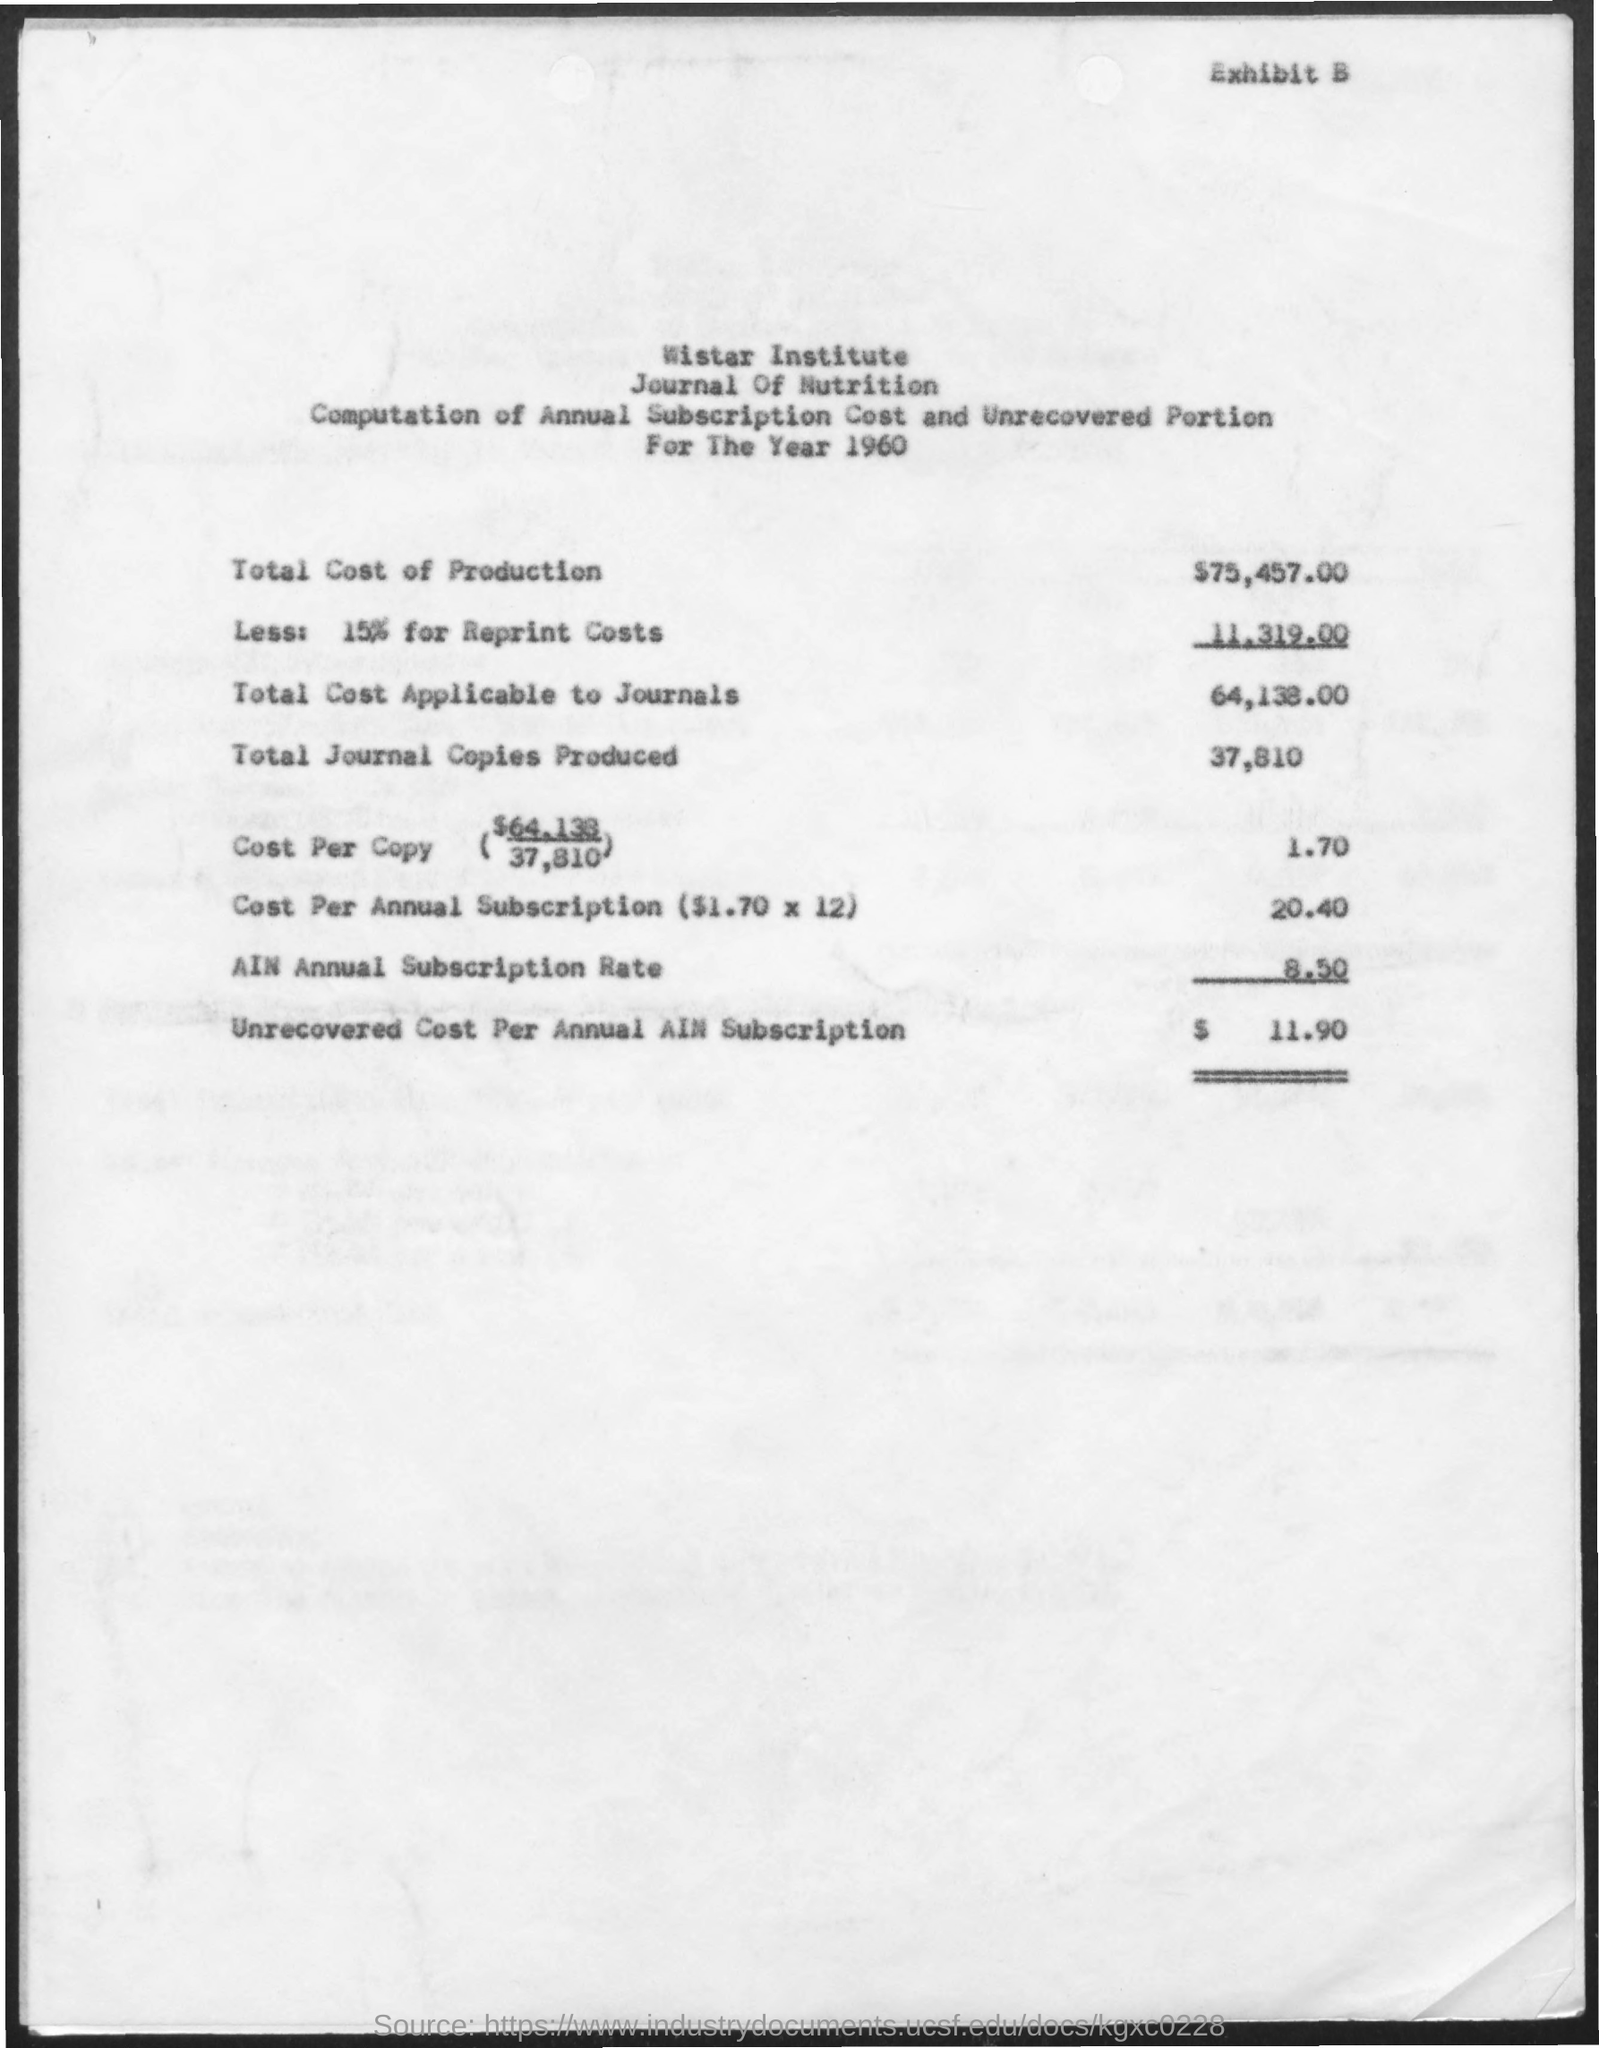What is the name of the institute mentioned ?
Ensure brevity in your answer.  WISTAR INSTITUTE. What is year mentioned
Offer a very short reply. 1960. What is the total cost of production ?
Offer a very short reply. $75,457.00. How much is the unrecovered cost per annual ain subscription
Your response must be concise. $11.90. 